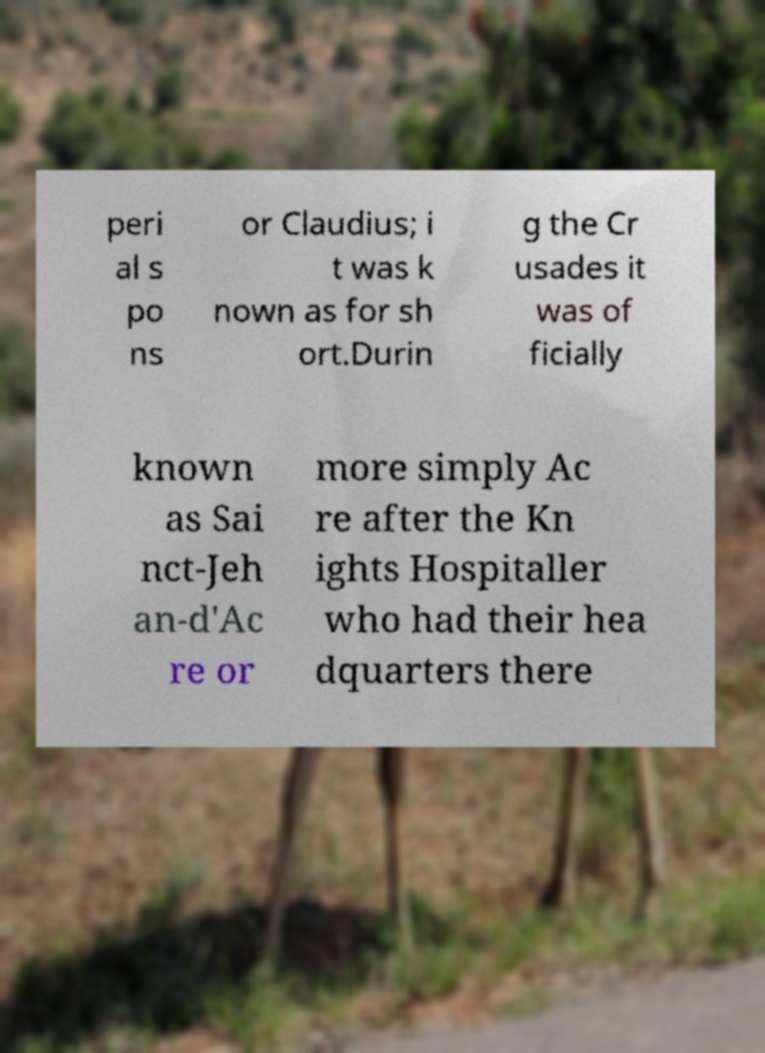I need the written content from this picture converted into text. Can you do that? peri al s po ns or Claudius; i t was k nown as for sh ort.Durin g the Cr usades it was of ficially known as Sai nct-Jeh an-d'Ac re or more simply Ac re after the Kn ights Hospitaller who had their hea dquarters there 